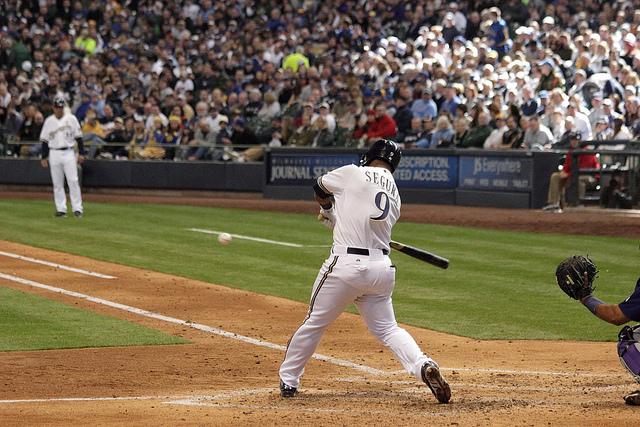What number is the batter?
Short answer required. 9. Is the person's right foot touching the ground?
Short answer required. Yes. What's the number on his back?
Write a very short answer. 9. What is the batters name?
Keep it brief. Segur. Is the ball moving?
Keep it brief. Yes. Does at least one of the ads seem to be from a newspaper?
Write a very short answer. Yes. 